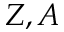<formula> <loc_0><loc_0><loc_500><loc_500>Z , A</formula> 